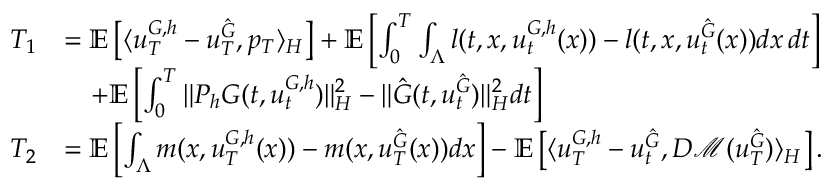<formula> <loc_0><loc_0><loc_500><loc_500>\begin{array} { r l } { T _ { 1 } } & { = \mathbb { E } \left [ \langle u _ { T } ^ { G , h } - u _ { T } ^ { \hat { G } } , p _ { T } \rangle _ { H } \right ] + \mathbb { E } \left [ \int _ { 0 } ^ { T } \int _ { \Lambda } l ( t , x , u _ { t } ^ { G , h } ( x ) ) - l ( t , x , u _ { t } ^ { \hat { G } } ( x ) ) d x \, d t \right ] } \\ & { \quad + \mathbb { E } \left [ \int _ { 0 } ^ { T } \| P _ { h } G ( t , u _ { t } ^ { G , h } ) \| _ { H } ^ { 2 } - \| \hat { G } ( t , u _ { t } ^ { \hat { G } } ) \| _ { H } ^ { 2 } d t \right ] } \\ { T _ { 2 } } & { = \mathbb { E } \left [ \int _ { \Lambda } m ( x , u _ { T } ^ { G , h } ( x ) ) - m ( x , u _ { T } ^ { \hat { G } } ( x ) ) d x \right ] - \mathbb { E } \left [ \langle u _ { T } ^ { G , h } - u _ { t } ^ { \hat { G } } , D \mathcal { M } ( u _ { T } ^ { \hat { G } } ) \rangle _ { H } \right ] . } \end{array}</formula> 